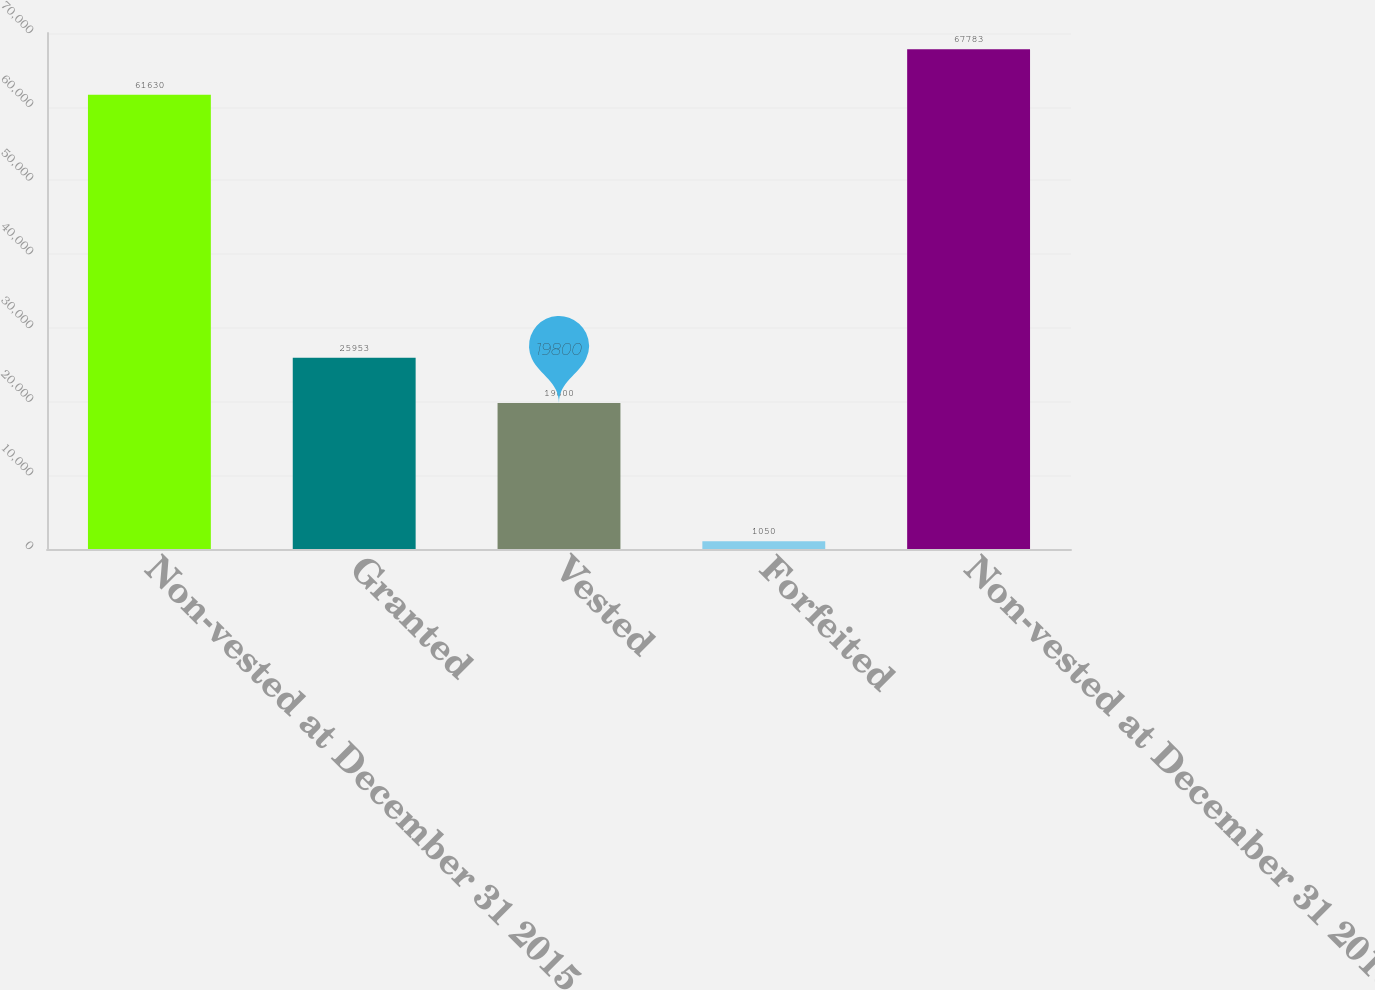Convert chart to OTSL. <chart><loc_0><loc_0><loc_500><loc_500><bar_chart><fcel>Non-vested at December 31 2015<fcel>Granted<fcel>Vested<fcel>Forfeited<fcel>Non-vested at December 31 2016<nl><fcel>61630<fcel>25953<fcel>19800<fcel>1050<fcel>67783<nl></chart> 